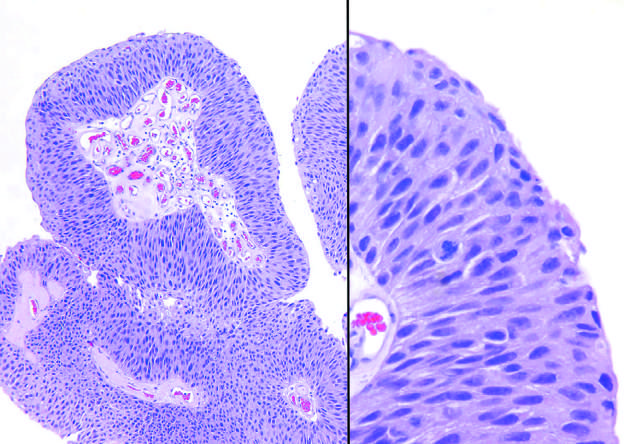does wound around one another with regularly spaced binding of the congo red show slightly irregular nuclei with scattered mitotic figures?
Answer the question using a single word or phrase. No 